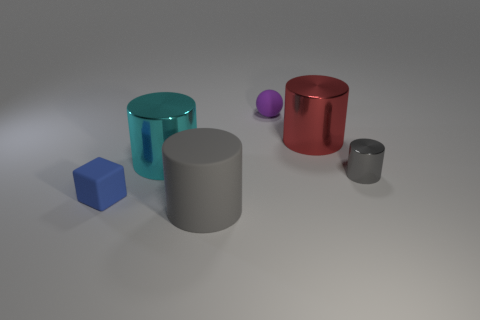Can you describe the lighting direction in this scene? The lighting in the scene appears to be coming from above, casting soft, diffused shadows directly beneath each object. The absence of harsh shadows and the gentle gradient on the surface suggests that the light source is large, or there are multiple light sources providing ambient illumination to the scene. 